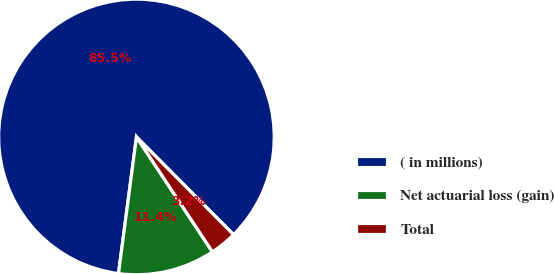Convert chart. <chart><loc_0><loc_0><loc_500><loc_500><pie_chart><fcel>( in millions)<fcel>Net actuarial loss (gain)<fcel>Total<nl><fcel>85.47%<fcel>11.38%<fcel>3.15%<nl></chart> 